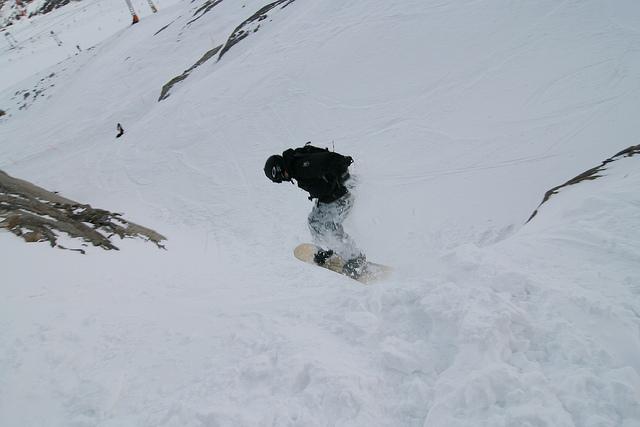What sport is this?
Quick response, please. Snowboarding. What is the man doing on the ski slope with the two ski poles?
Concise answer only. Snowboarding. What color is the snowboard?
Be succinct. White. Does he wear head protection?
Give a very brief answer. Yes. 